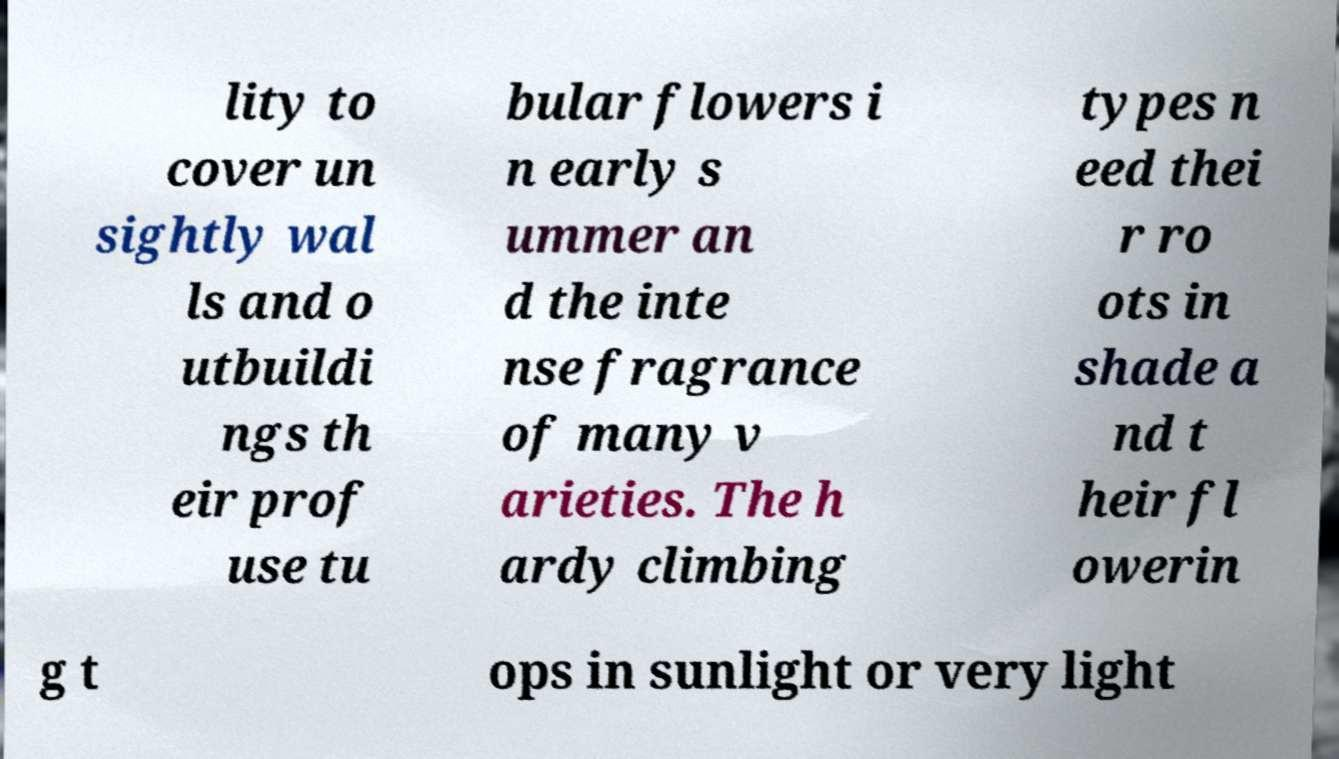Can you accurately transcribe the text from the provided image for me? lity to cover un sightly wal ls and o utbuildi ngs th eir prof use tu bular flowers i n early s ummer an d the inte nse fragrance of many v arieties. The h ardy climbing types n eed thei r ro ots in shade a nd t heir fl owerin g t ops in sunlight or very light 